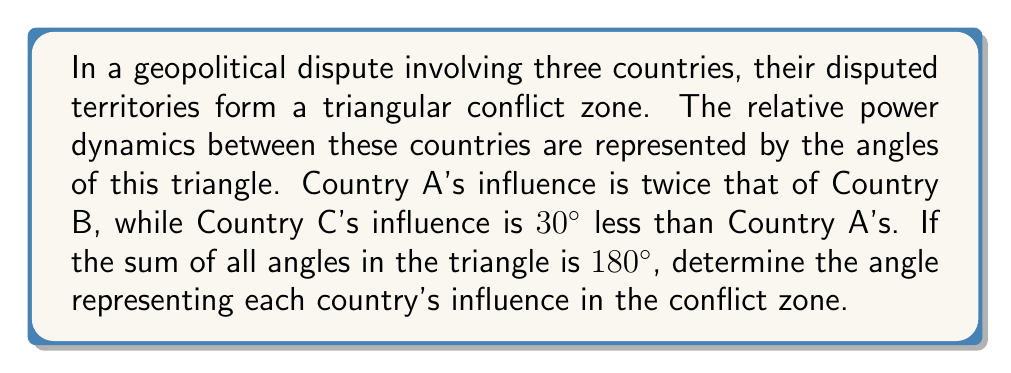Can you answer this question? Let's approach this step-by-step:

1) Let $x$ represent the angle for Country B's influence.

2) Given that Country A's influence is twice that of Country B, its angle will be $2x$.

3) Country C's influence is 30° less than Country A's, so its angle will be $2x - 30°$.

4) We know that the sum of angles in a triangle is 180°. So we can set up the equation:

   $x + 2x + (2x - 30°) = 180°$

5) Simplify the left side of the equation:
   
   $5x - 30° = 180°$

6) Add 30° to both sides:
   
   $5x = 210°$

7) Divide both sides by 5:
   
   $x = 42°$

8) Now we can calculate the angles for each country:
   - Country B: $x = 42°$
   - Country A: $2x = 2(42°) = 84°$
   - Country C: $2x - 30° = 84° - 30° = 54°$

9) Verify: $42° + 84° + 54° = 180°$

[asy]
import geometry;

size(200);
pair A = (0,0), B = (100,0), C = (50,86.6);
draw(A--B--C--A);
label("A", A, SW);
label("B", B, SE);
label("C", C, N);
label("84°", A, NE);
label("42°", B, NW);
label("54°", C, S);
[/asy]
Answer: Country A: 84°
Country B: 42°
Country C: 54° 